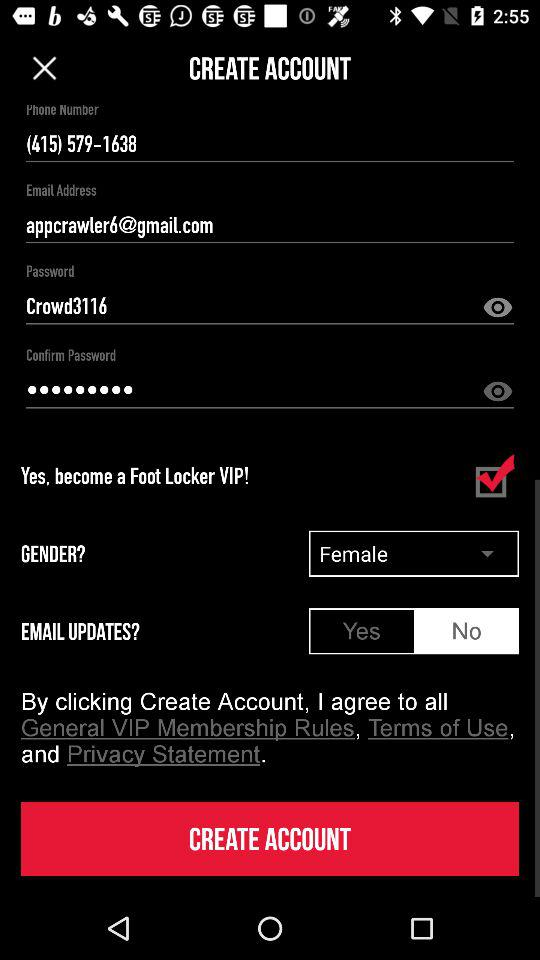What option is checked marked? The option that is checked marked is "Yes, become a Foot Locker VIP!". 